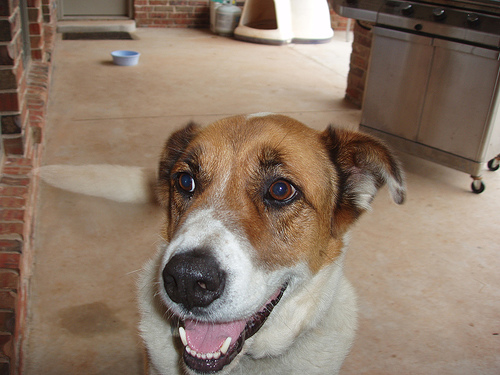<image>
Is there a dog ear under the grill? No. The dog ear is not positioned under the grill. The vertical relationship between these objects is different. Is there a grill to the right of the dish? Yes. From this viewpoint, the grill is positioned to the right side relative to the dish. Is the carpet stain in front of the dog? No. The carpet stain is not in front of the dog. The spatial positioning shows a different relationship between these objects. 